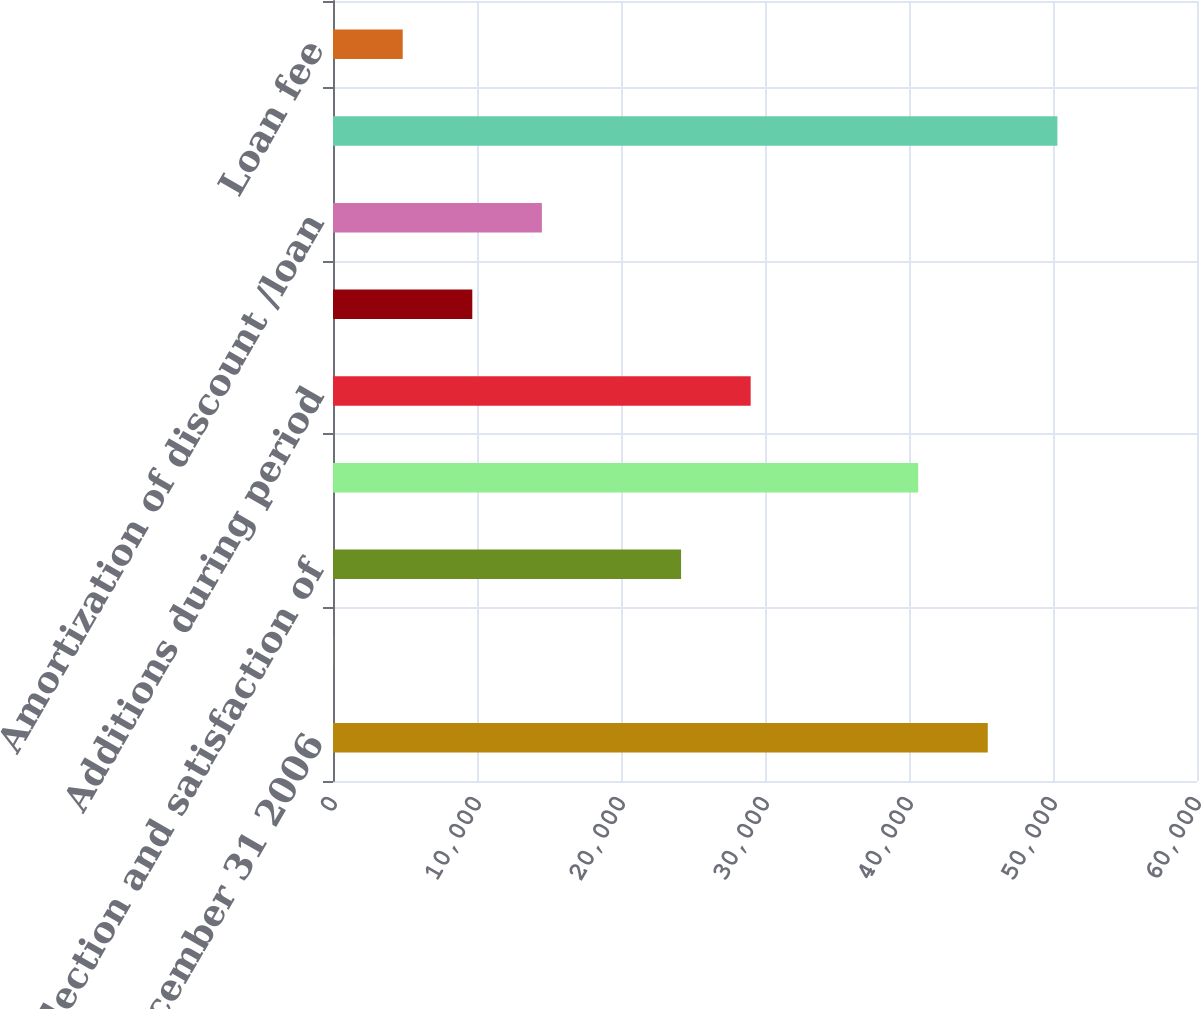Convert chart to OTSL. <chart><loc_0><loc_0><loc_500><loc_500><bar_chart><fcel>Balance December 31 2006<fcel>Issuance of loans<fcel>Collection and satisfaction of<fcel>Balance December 31 2007<fcel>Additions during period<fcel>Loan fee Deductions during<fcel>Amortization of discount /loan<fcel>Balance December 31 2008<fcel>Loan fee<nl><fcel>45470.8<fcel>8<fcel>24172<fcel>40638<fcel>29004.8<fcel>9673.6<fcel>14506.4<fcel>50303.6<fcel>4840.8<nl></chart> 